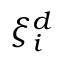<formula> <loc_0><loc_0><loc_500><loc_500>\xi _ { i } ^ { d }</formula> 